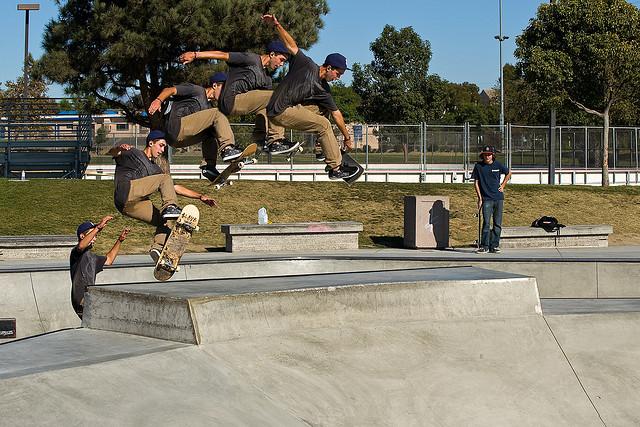Where is this?
Short answer required. Skate park. How many people are skating?
Quick response, please. 1. What material is the skate park made out of?
Write a very short answer. Concrete. 